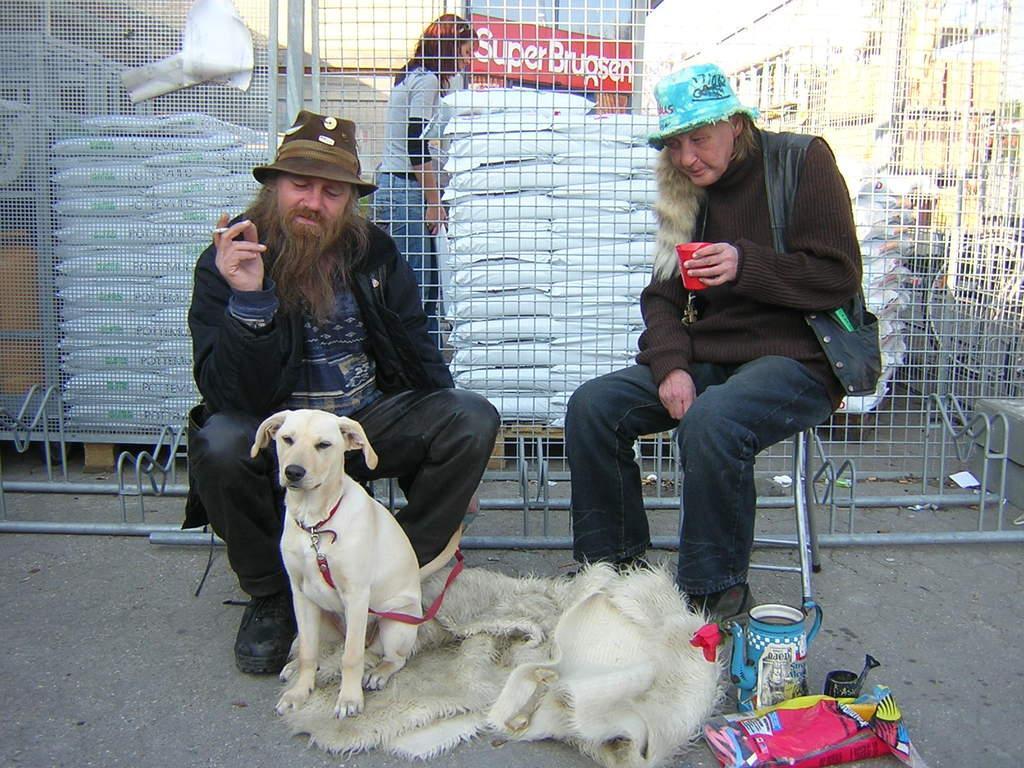How would you summarize this image in a sentence or two? In the image there are two persons sat on chair,in front of them there is a carpet and a dog on carpet and beside that there is a jug and a cloth. Backside of them is a there is a railing and to the whole background there is store named super bracken. A woman with all backsack. There are many buildings on to the right side corner in the background. 